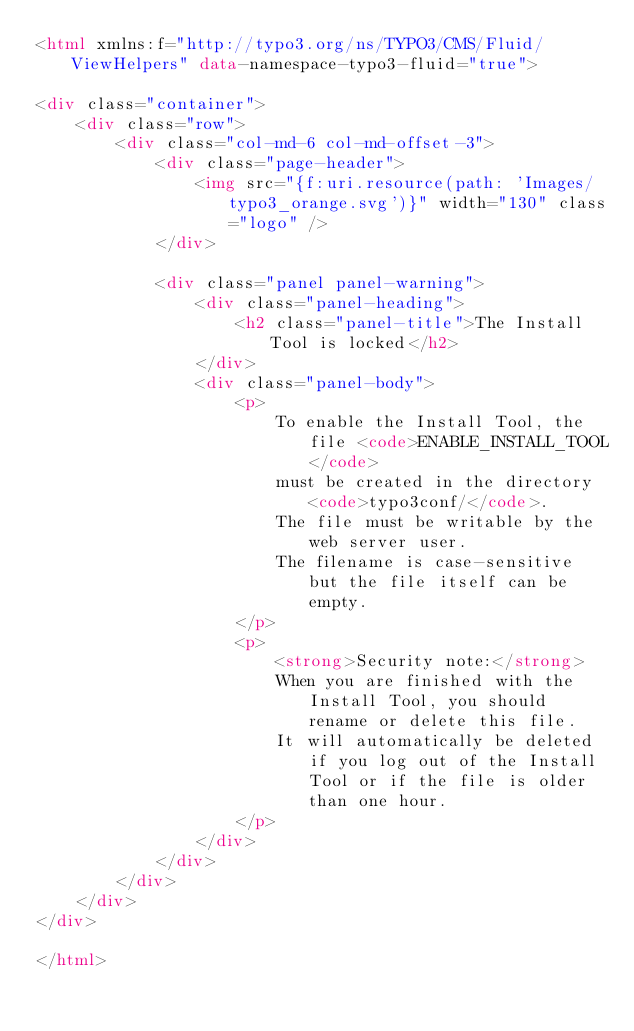<code> <loc_0><loc_0><loc_500><loc_500><_HTML_><html xmlns:f="http://typo3.org/ns/TYPO3/CMS/Fluid/ViewHelpers" data-namespace-typo3-fluid="true">

<div class="container">
    <div class="row">
        <div class="col-md-6 col-md-offset-3">
            <div class="page-header">
                <img src="{f:uri.resource(path: 'Images/typo3_orange.svg')}" width="130" class="logo" />
            </div>

            <div class="panel panel-warning">
                <div class="panel-heading">
                    <h2 class="panel-title">The Install Tool is locked</h2>
                </div>
                <div class="panel-body">
                    <p>
                        To enable the Install Tool, the file <code>ENABLE_INSTALL_TOOL</code>
                        must be created in the directory <code>typo3conf/</code>.
                        The file must be writable by the web server user.
                        The filename is case-sensitive but the file itself can be empty.
                    </p>
                    <p>
                        <strong>Security note:</strong>
                        When you are finished with the Install Tool, you should rename or delete this file.
                        It will automatically be deleted if you log out of the Install Tool or if the file is older than one hour.
                    </p>
                </div>
            </div>
        </div>
    </div>
</div>

</html>
</code> 